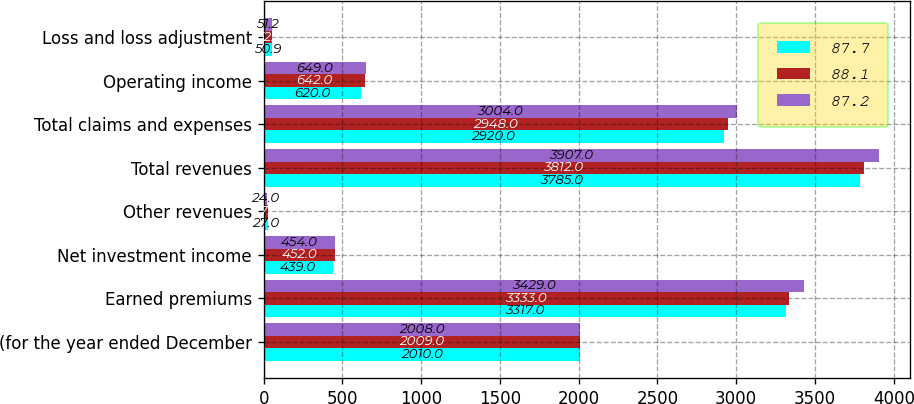Convert chart. <chart><loc_0><loc_0><loc_500><loc_500><stacked_bar_chart><ecel><fcel>(for the year ended December<fcel>Earned premiums<fcel>Net investment income<fcel>Other revenues<fcel>Total revenues<fcel>Total claims and expenses<fcel>Operating income<fcel>Loss and loss adjustment<nl><fcel>87.7<fcel>2010<fcel>3317<fcel>439<fcel>27<fcel>3785<fcel>2920<fcel>620<fcel>50.9<nl><fcel>88.1<fcel>2009<fcel>3333<fcel>452<fcel>27<fcel>3812<fcel>2948<fcel>642<fcel>52.1<nl><fcel>87.2<fcel>2008<fcel>3429<fcel>454<fcel>24<fcel>3907<fcel>3004<fcel>649<fcel>51.2<nl></chart> 